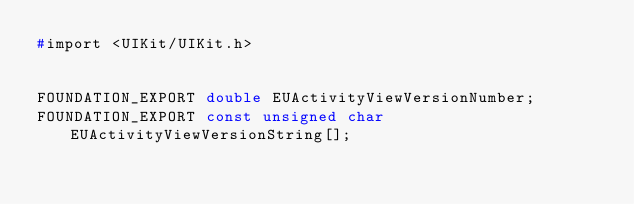Convert code to text. <code><loc_0><loc_0><loc_500><loc_500><_C_>#import <UIKit/UIKit.h>


FOUNDATION_EXPORT double EUActivityViewVersionNumber;
FOUNDATION_EXPORT const unsigned char EUActivityViewVersionString[];

</code> 